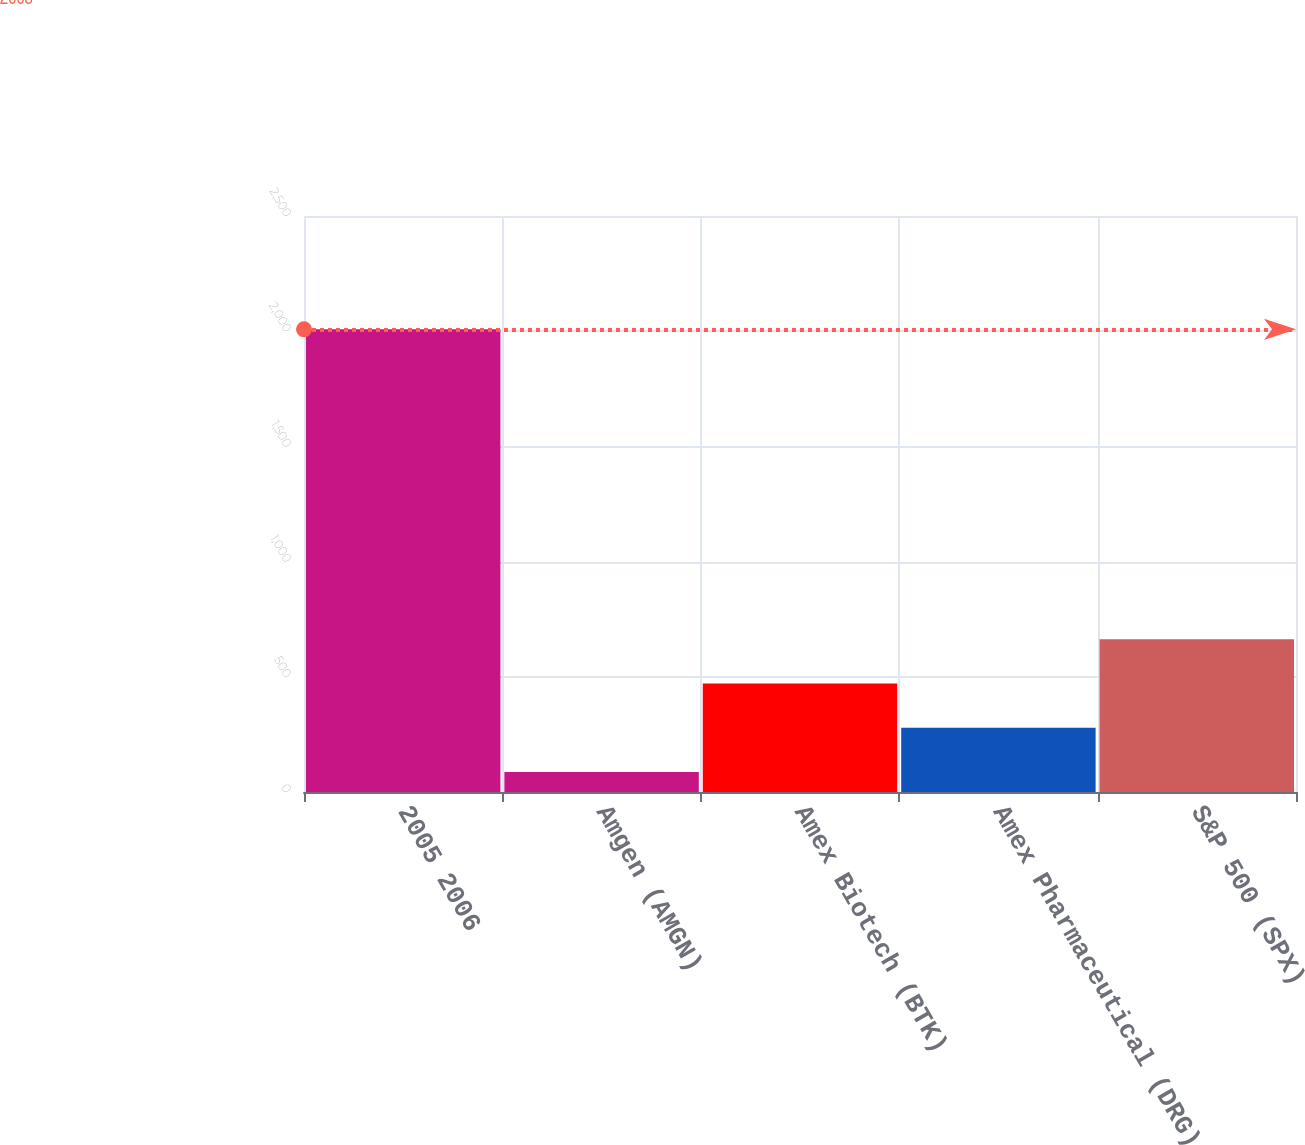Convert chart. <chart><loc_0><loc_0><loc_500><loc_500><bar_chart><fcel>2005 2006<fcel>Amgen (AMGN)<fcel>Amex Biotech (BTK)<fcel>Amex Pharmaceutical (DRG)<fcel>S&P 500 (SPX)<nl><fcel>2008<fcel>86.62<fcel>470.9<fcel>278.76<fcel>663.04<nl></chart> 